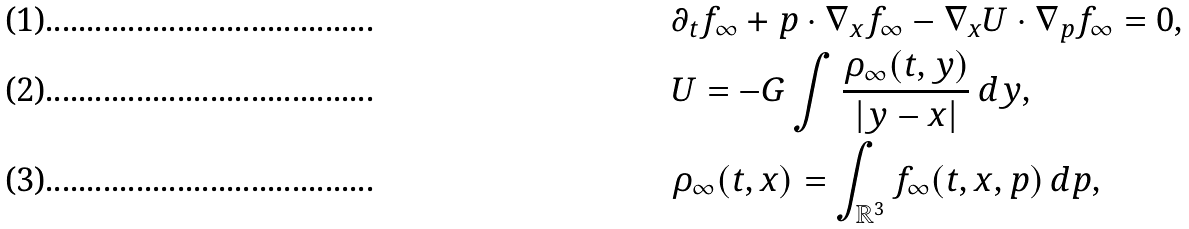<formula> <loc_0><loc_0><loc_500><loc_500>& \partial _ { t } f _ { \infty } + p \cdot \nabla _ { x } f _ { \infty } - \nabla _ { x } U \cdot \nabla _ { p } f _ { \infty } = 0 , \\ & U = - G \int \frac { \rho _ { \infty } ( t , y ) } { | y - x | } \, d y , \\ & \rho _ { \infty } ( t , x ) = \int _ { \mathbb { R } ^ { 3 } } f _ { \infty } ( t , x , p ) \, d p ,</formula> 